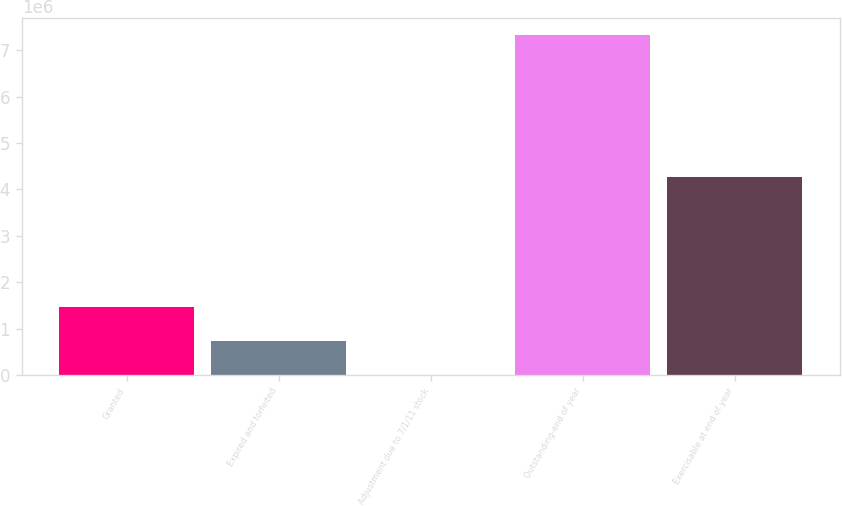Convert chart. <chart><loc_0><loc_0><loc_500><loc_500><bar_chart><fcel>Granted<fcel>Expired and forfeited<fcel>Adjustment due to 7/1/11 stock<fcel>Outstanding-end of year<fcel>Exercisable at end of year<nl><fcel>1.46643e+06<fcel>733214<fcel>0.79<fcel>7.33214e+06<fcel>4.26182e+06<nl></chart> 